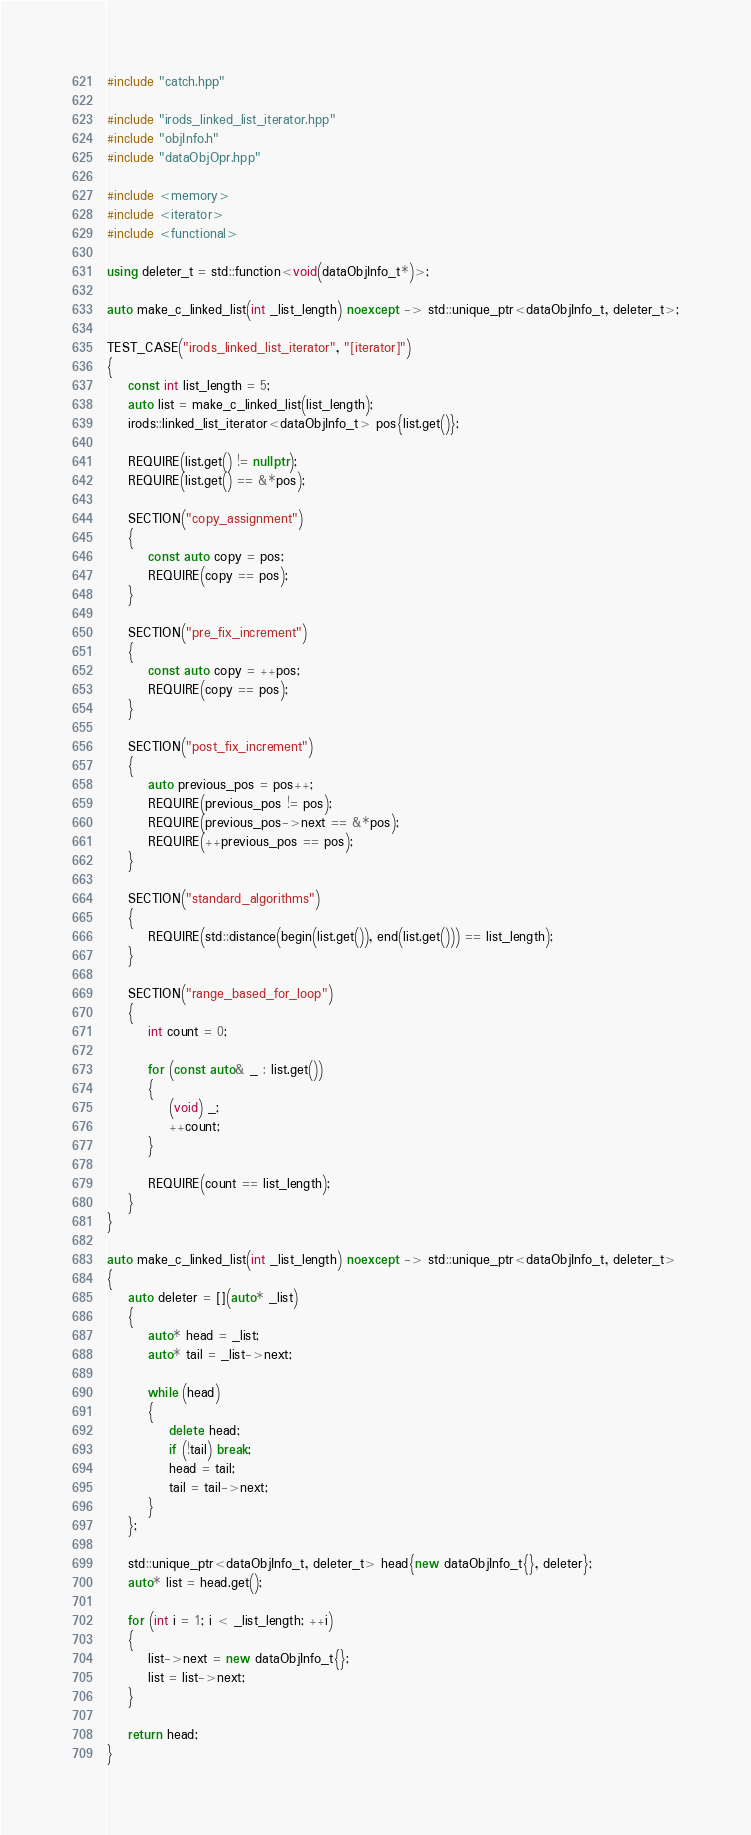<code> <loc_0><loc_0><loc_500><loc_500><_C++_>#include "catch.hpp"

#include "irods_linked_list_iterator.hpp"
#include "objInfo.h"
#include "dataObjOpr.hpp"

#include <memory>
#include <iterator>
#include <functional>

using deleter_t = std::function<void(dataObjInfo_t*)>;

auto make_c_linked_list(int _list_length) noexcept -> std::unique_ptr<dataObjInfo_t, deleter_t>;

TEST_CASE("irods_linked_list_iterator", "[iterator]")
{
    const int list_length = 5;
    auto list = make_c_linked_list(list_length);
    irods::linked_list_iterator<dataObjInfo_t> pos{list.get()};

    REQUIRE(list.get() != nullptr);
    REQUIRE(list.get() == &*pos);

    SECTION("copy_assignment")
    {
        const auto copy = pos;
        REQUIRE(copy == pos);
    }

    SECTION("pre_fix_increment")
    {
        const auto copy = ++pos;
        REQUIRE(copy == pos);
    }

    SECTION("post_fix_increment")
    {
        auto previous_pos = pos++;
        REQUIRE(previous_pos != pos);
        REQUIRE(previous_pos->next == &*pos);
        REQUIRE(++previous_pos == pos);
    }

    SECTION("standard_algorithms")
    {
        REQUIRE(std::distance(begin(list.get()), end(list.get())) == list_length);
    }

    SECTION("range_based_for_loop")
    {
        int count = 0;

        for (const auto& _ : list.get())
        {
            (void) _;
            ++count;
        }

        REQUIRE(count == list_length);
    }
}

auto make_c_linked_list(int _list_length) noexcept -> std::unique_ptr<dataObjInfo_t, deleter_t>
{
    auto deleter = [](auto* _list)
    {
        auto* head = _list;
        auto* tail = _list->next;

        while (head)
        {
            delete head;
            if (!tail) break;
            head = tail;
            tail = tail->next;
        }
    };

    std::unique_ptr<dataObjInfo_t, deleter_t> head{new dataObjInfo_t{}, deleter};
    auto* list = head.get();

    for (int i = 1; i < _list_length; ++i)
    {
        list->next = new dataObjInfo_t{};
        list = list->next;
    }

    return head;
}

</code> 